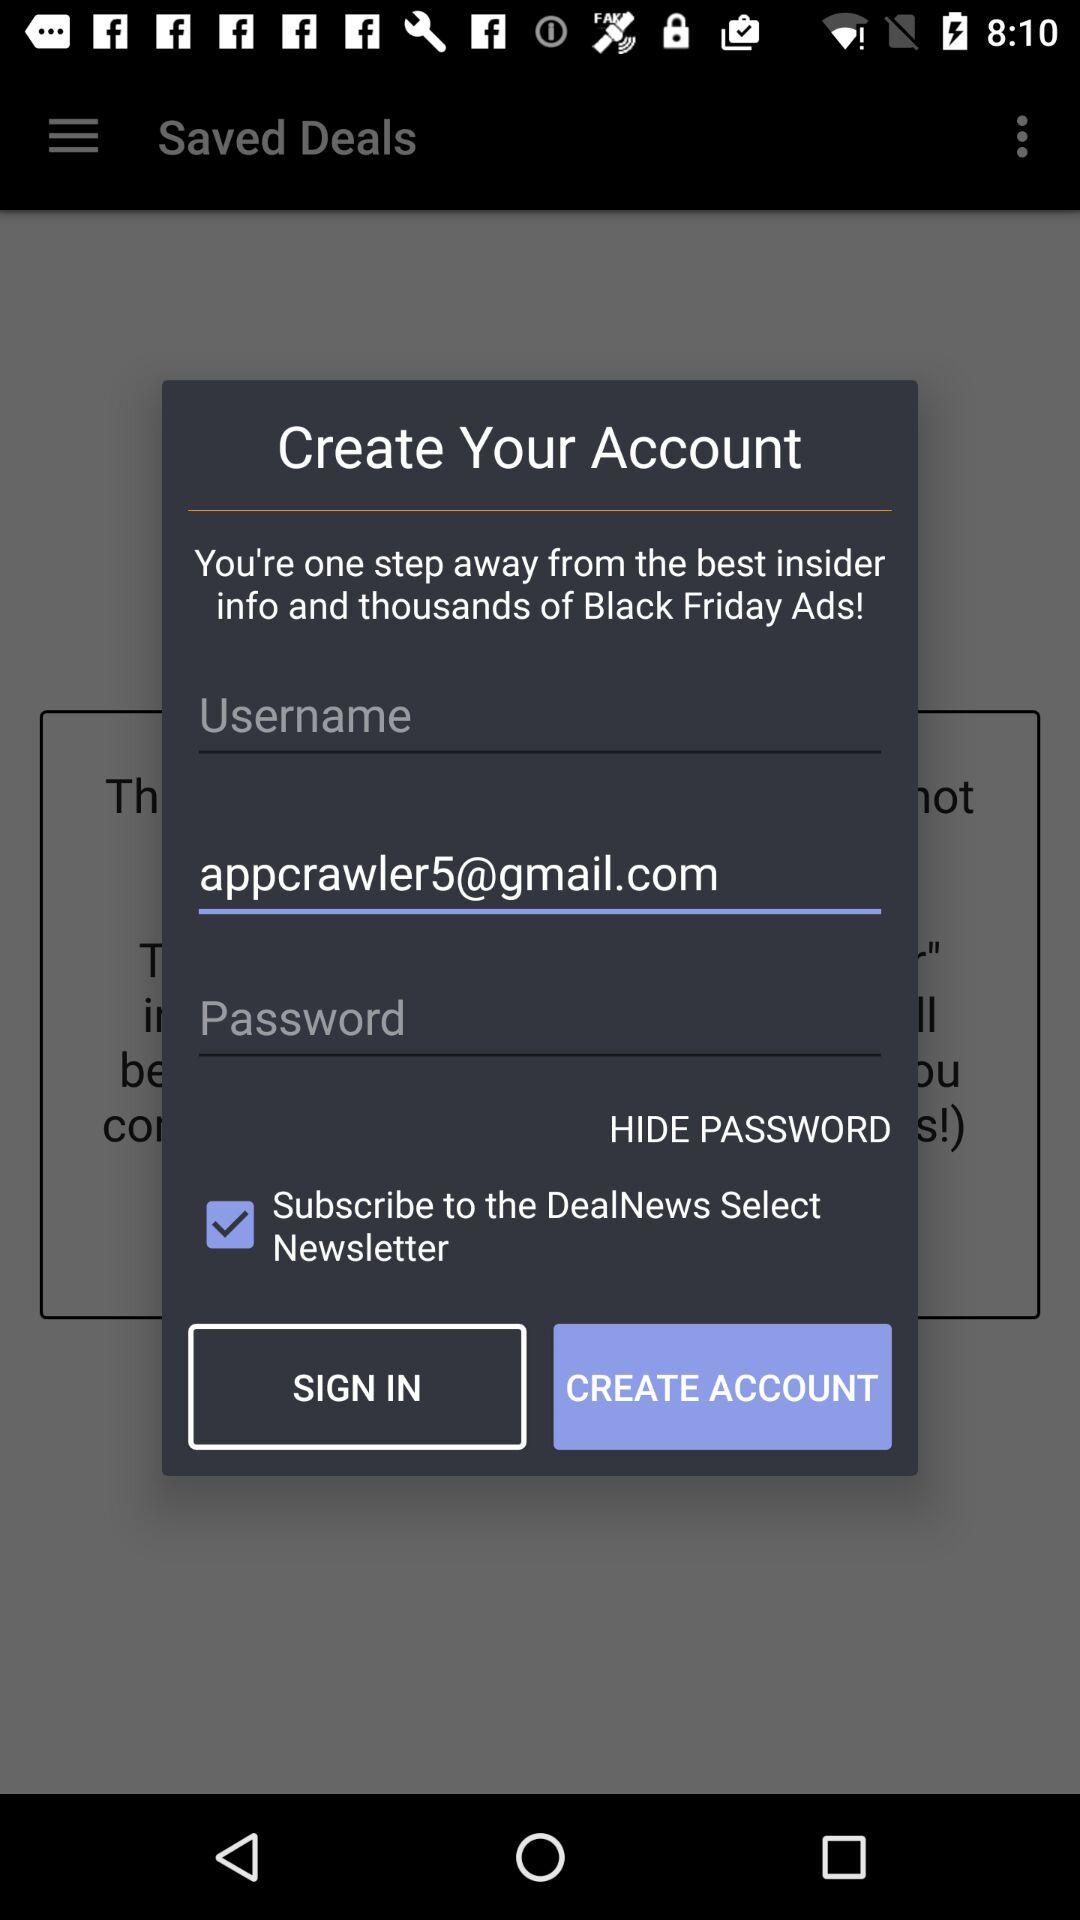Which option is marked as checked? The option "Subscribe to the DealNews Select Newsletter" is marked as checked. 